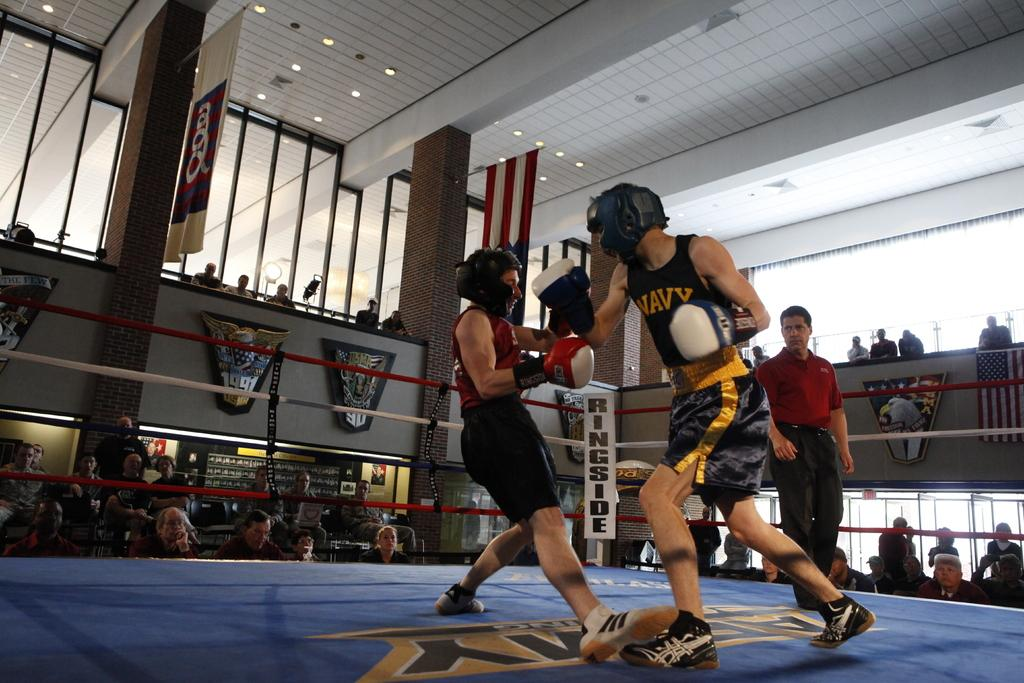<image>
Provide a brief description of the given image. The two young men are boxing in a ring, one has NAVY written on his shirt. 